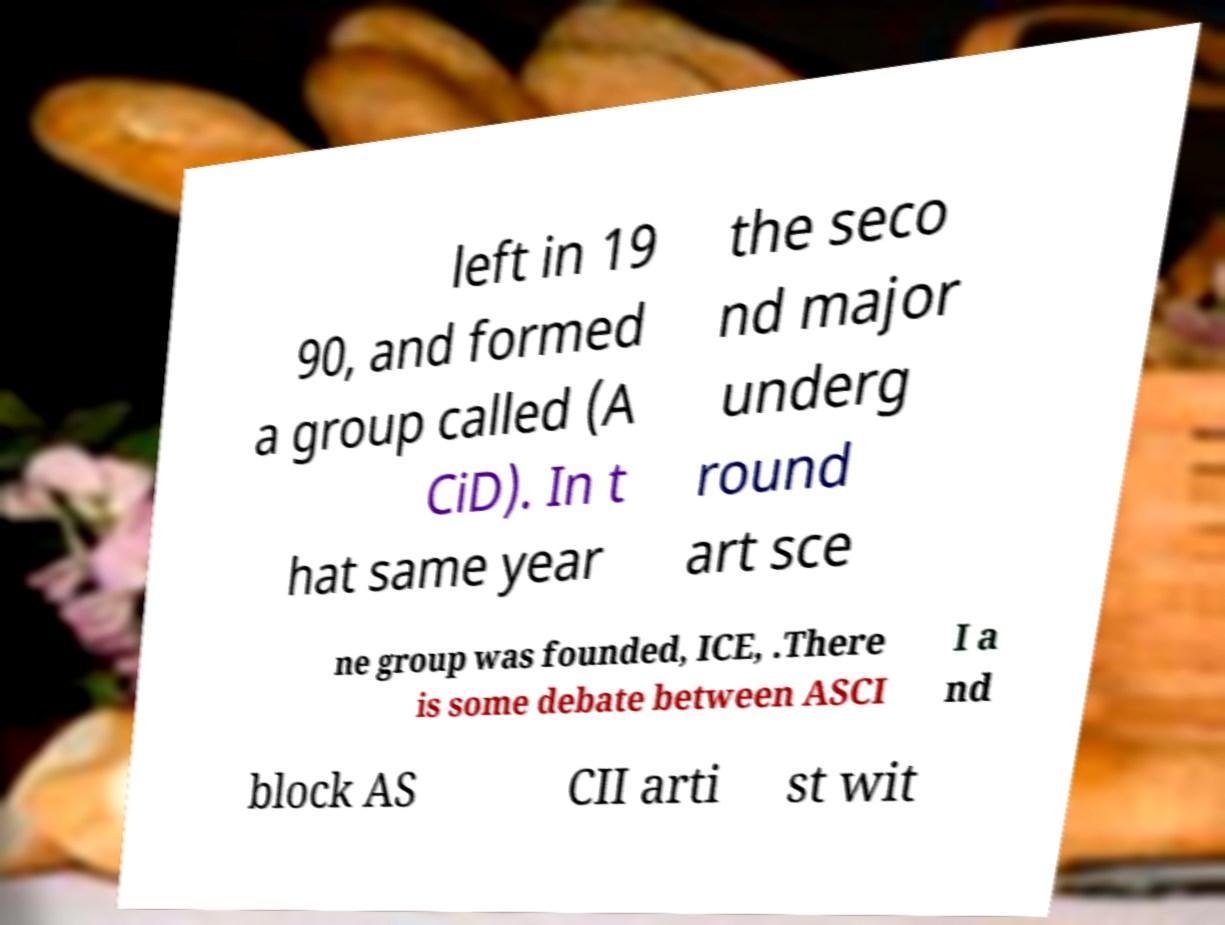Could you assist in decoding the text presented in this image and type it out clearly? left in 19 90, and formed a group called (A CiD). In t hat same year the seco nd major underg round art sce ne group was founded, ICE, .There is some debate between ASCI I a nd block AS CII arti st wit 